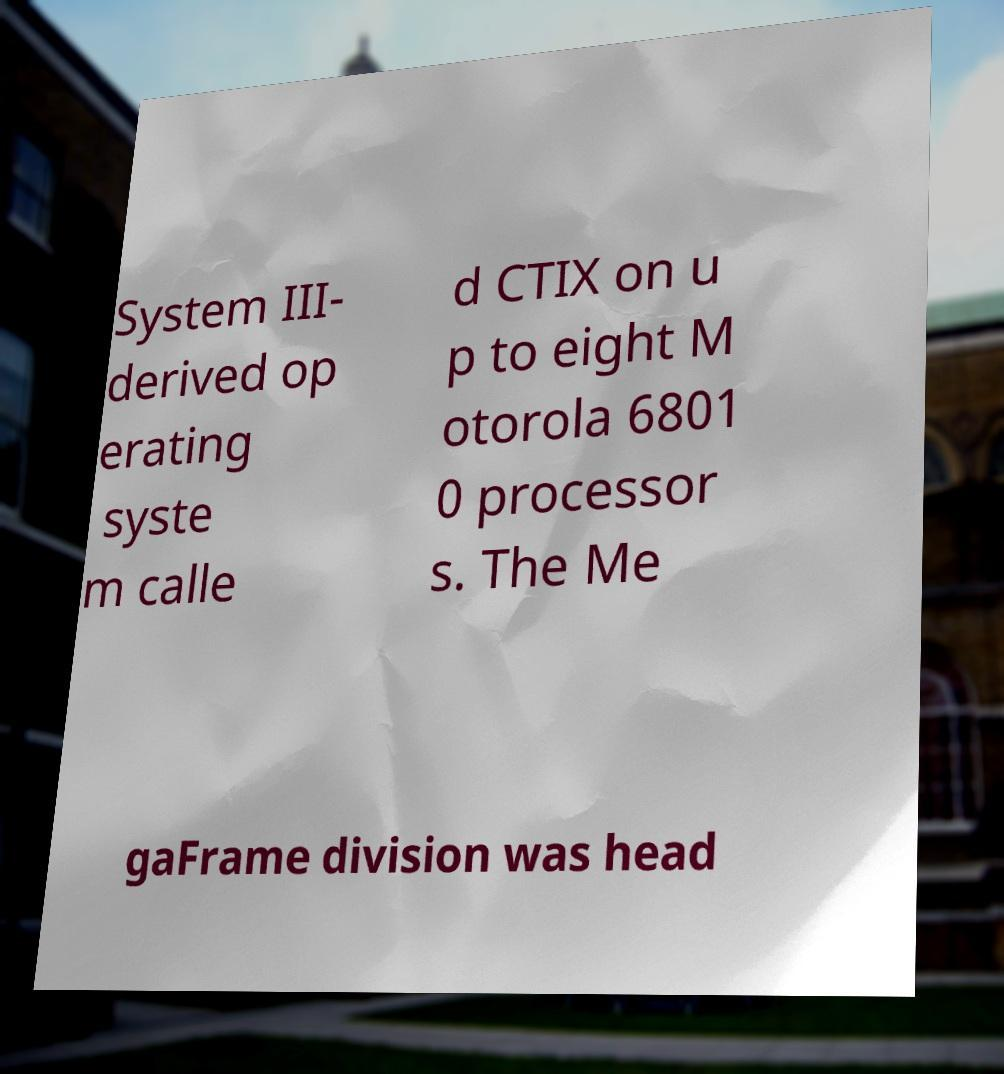Please identify and transcribe the text found in this image. System III- derived op erating syste m calle d CTIX on u p to eight M otorola 6801 0 processor s. The Me gaFrame division was head 